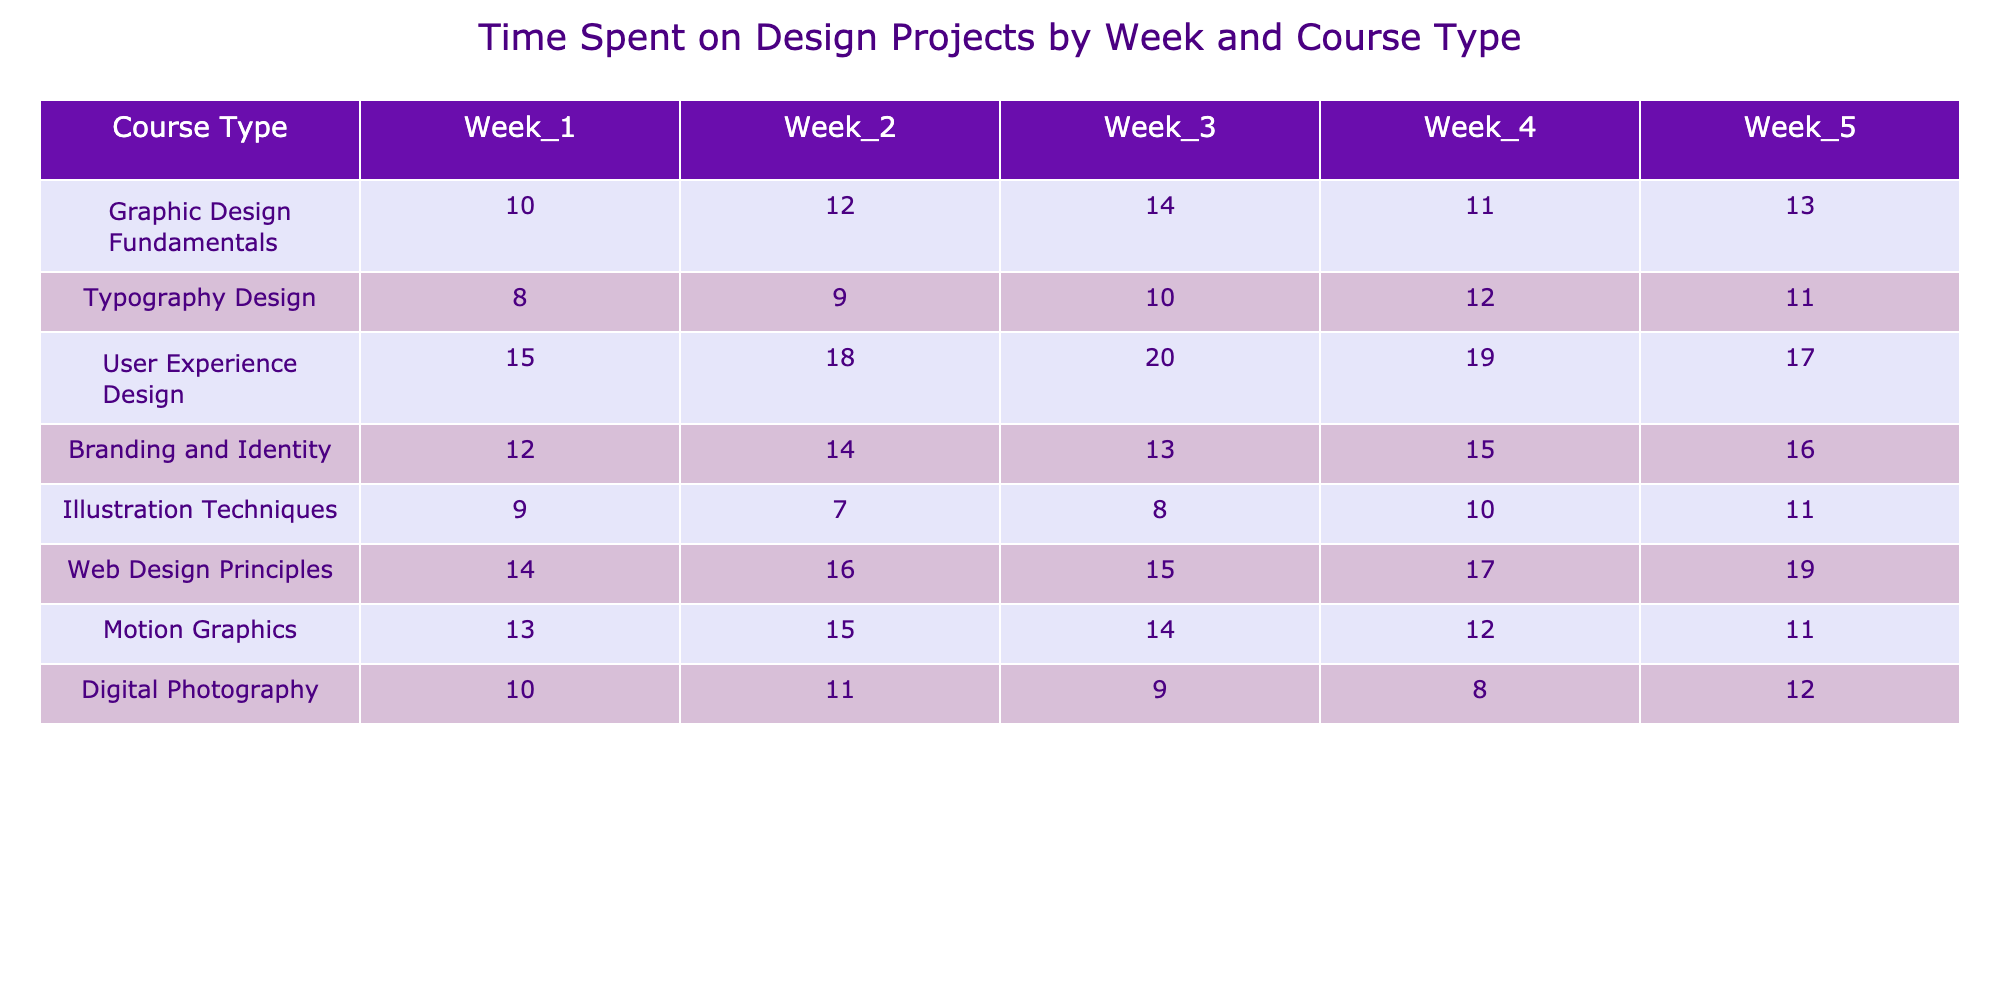What is the total time spent on User Experience Design in Week 3? For User Experience Design in Week 3, the table shows a value of 20 for the hours spent. Therefore, the total time spent is simply this value.
Answer: 20 Which course type spent the least time in Week 2? In Week 2, we have Typography Design with 9 hours, Illustration Techniques with 7 hours, and the other courses with higher values. The lowest value is from Illustration Techniques.
Answer: 7 What is the average time spent on Branding and Identity over the five weeks? The time spent on Branding and Identity is 12, 14, 13, 15, and 16 across the weeks. Adding these gives 12 + 14 + 13 + 15 + 16 = 70. Then, divide by the number of weeks (5), which results in 70/5 = 14.
Answer: 14 Did Motion Graphics spend more time in Week 1 than Web Design Principles? In Week 1, Motion Graphics spent 13 hours, while Web Design Principles spent 14 hours. Since 13 is less than 14, Motion Graphics did not spend more time.
Answer: No What was the total time spent on Graphic Design Fundamentals across all weeks? The time spent is 10, 12, 14, 11, and 13 for the five weeks. Summing these values gives 10 + 12 + 14 + 11 + 13 = 60. Therefore, the total time is 60 hours.
Answer: 60 Which course type has the maximum time spent in Week 5? Looking at Week 5, we compare the values: Graphic Design Fundamentals 13, Typography Design 11, User Experience Design 17, Branding and Identity 16, Illustration Techniques 11, Web Design Principles 19, Motion Graphics 11, and Digital Photography 12. The maximum value is from Web Design Principles at 19 hours.
Answer: 19 Was the time spent on Typography Design consistent across the weeks? The values for Typography Design are 8, 9, 10, 12, and 11. The values increase initially and then fluctuate without being the same in any week, indicating inconsistency.
Answer: No What is the difference in hours spent between Week 1 and Week 4 for Illustration Techniques? In Week 1, the hours for Illustration Techniques are 9, and in Week 4, they are 10. The difference is therefore 10 - 9 = 1 hour.
Answer: 1 Which course had the highest total time spent overall and what is that total? To find the course with the highest total, we calculate the total for each course: User Experience Design (89), Web Design Principles (81), and others are less than these. The highest is User Experience Design at 89 hours.
Answer: 89 